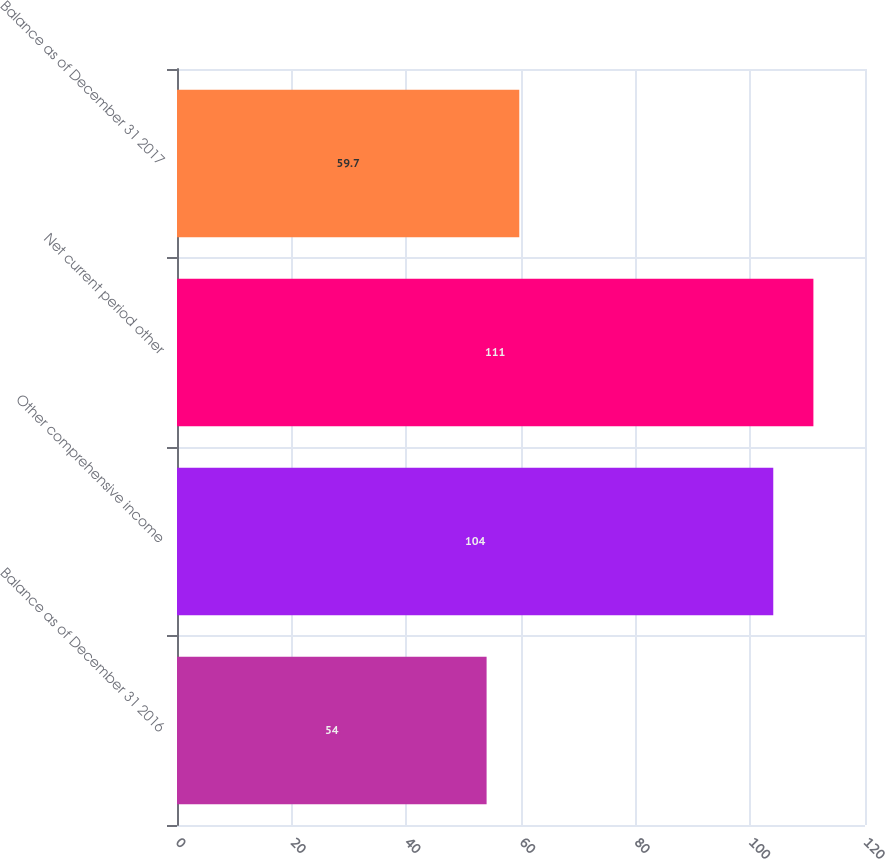Convert chart to OTSL. <chart><loc_0><loc_0><loc_500><loc_500><bar_chart><fcel>Balance as of December 31 2016<fcel>Other comprehensive income<fcel>Net current period other<fcel>Balance as of December 31 2017<nl><fcel>54<fcel>104<fcel>111<fcel>59.7<nl></chart> 